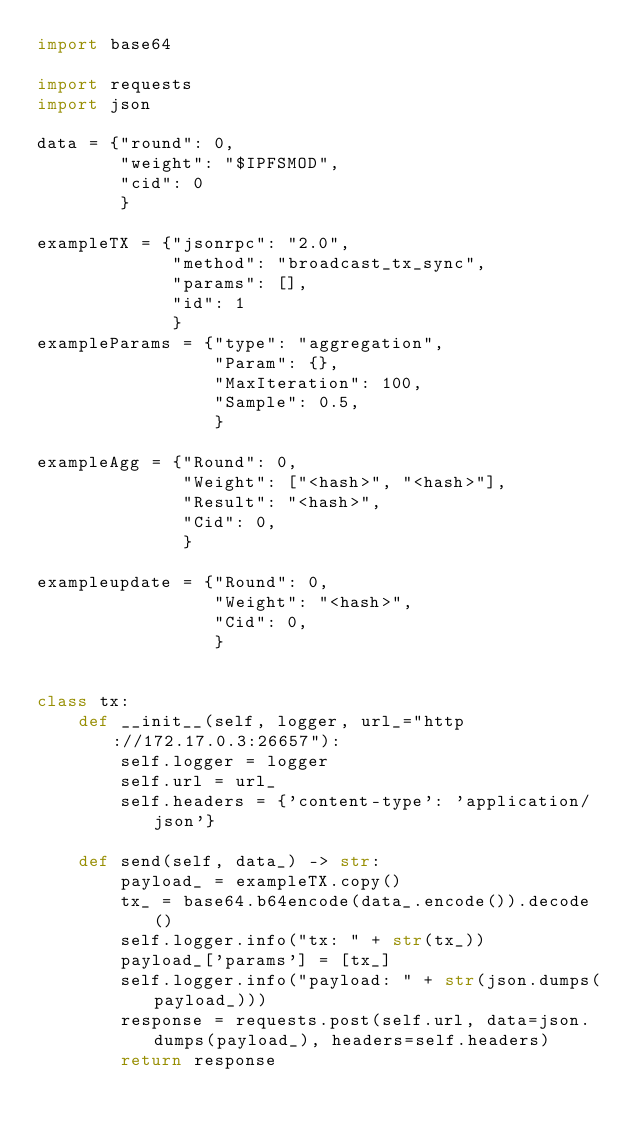<code> <loc_0><loc_0><loc_500><loc_500><_Python_>import base64

import requests
import json

data = {"round": 0,
        "weight": "$IPFSMOD",
        "cid": 0
        }

exampleTX = {"jsonrpc": "2.0",
             "method": "broadcast_tx_sync",
             "params": [],
             "id": 1
             }
exampleParams = {"type": "aggregation",
                 "Param": {},
                 "MaxIteration": 100,
                 "Sample": 0.5,
                 }

exampleAgg = {"Round": 0,
              "Weight": ["<hash>", "<hash>"],
              "Result": "<hash>",
              "Cid": 0,
              }

exampleupdate = {"Round": 0,
                 "Weight": "<hash>",
                 "Cid": 0,
                 }


class tx:
    def __init__(self, logger, url_="http://172.17.0.3:26657"):
        self.logger = logger
        self.url = url_
        self.headers = {'content-type': 'application/json'}

    def send(self, data_) -> str:
        payload_ = exampleTX.copy()
        tx_ = base64.b64encode(data_.encode()).decode()
        self.logger.info("tx: " + str(tx_))
        payload_['params'] = [tx_]
        self.logger.info("payload: " + str(json.dumps(payload_)))
        response = requests.post(self.url, data=json.dumps(payload_), headers=self.headers)
        return response

</code> 